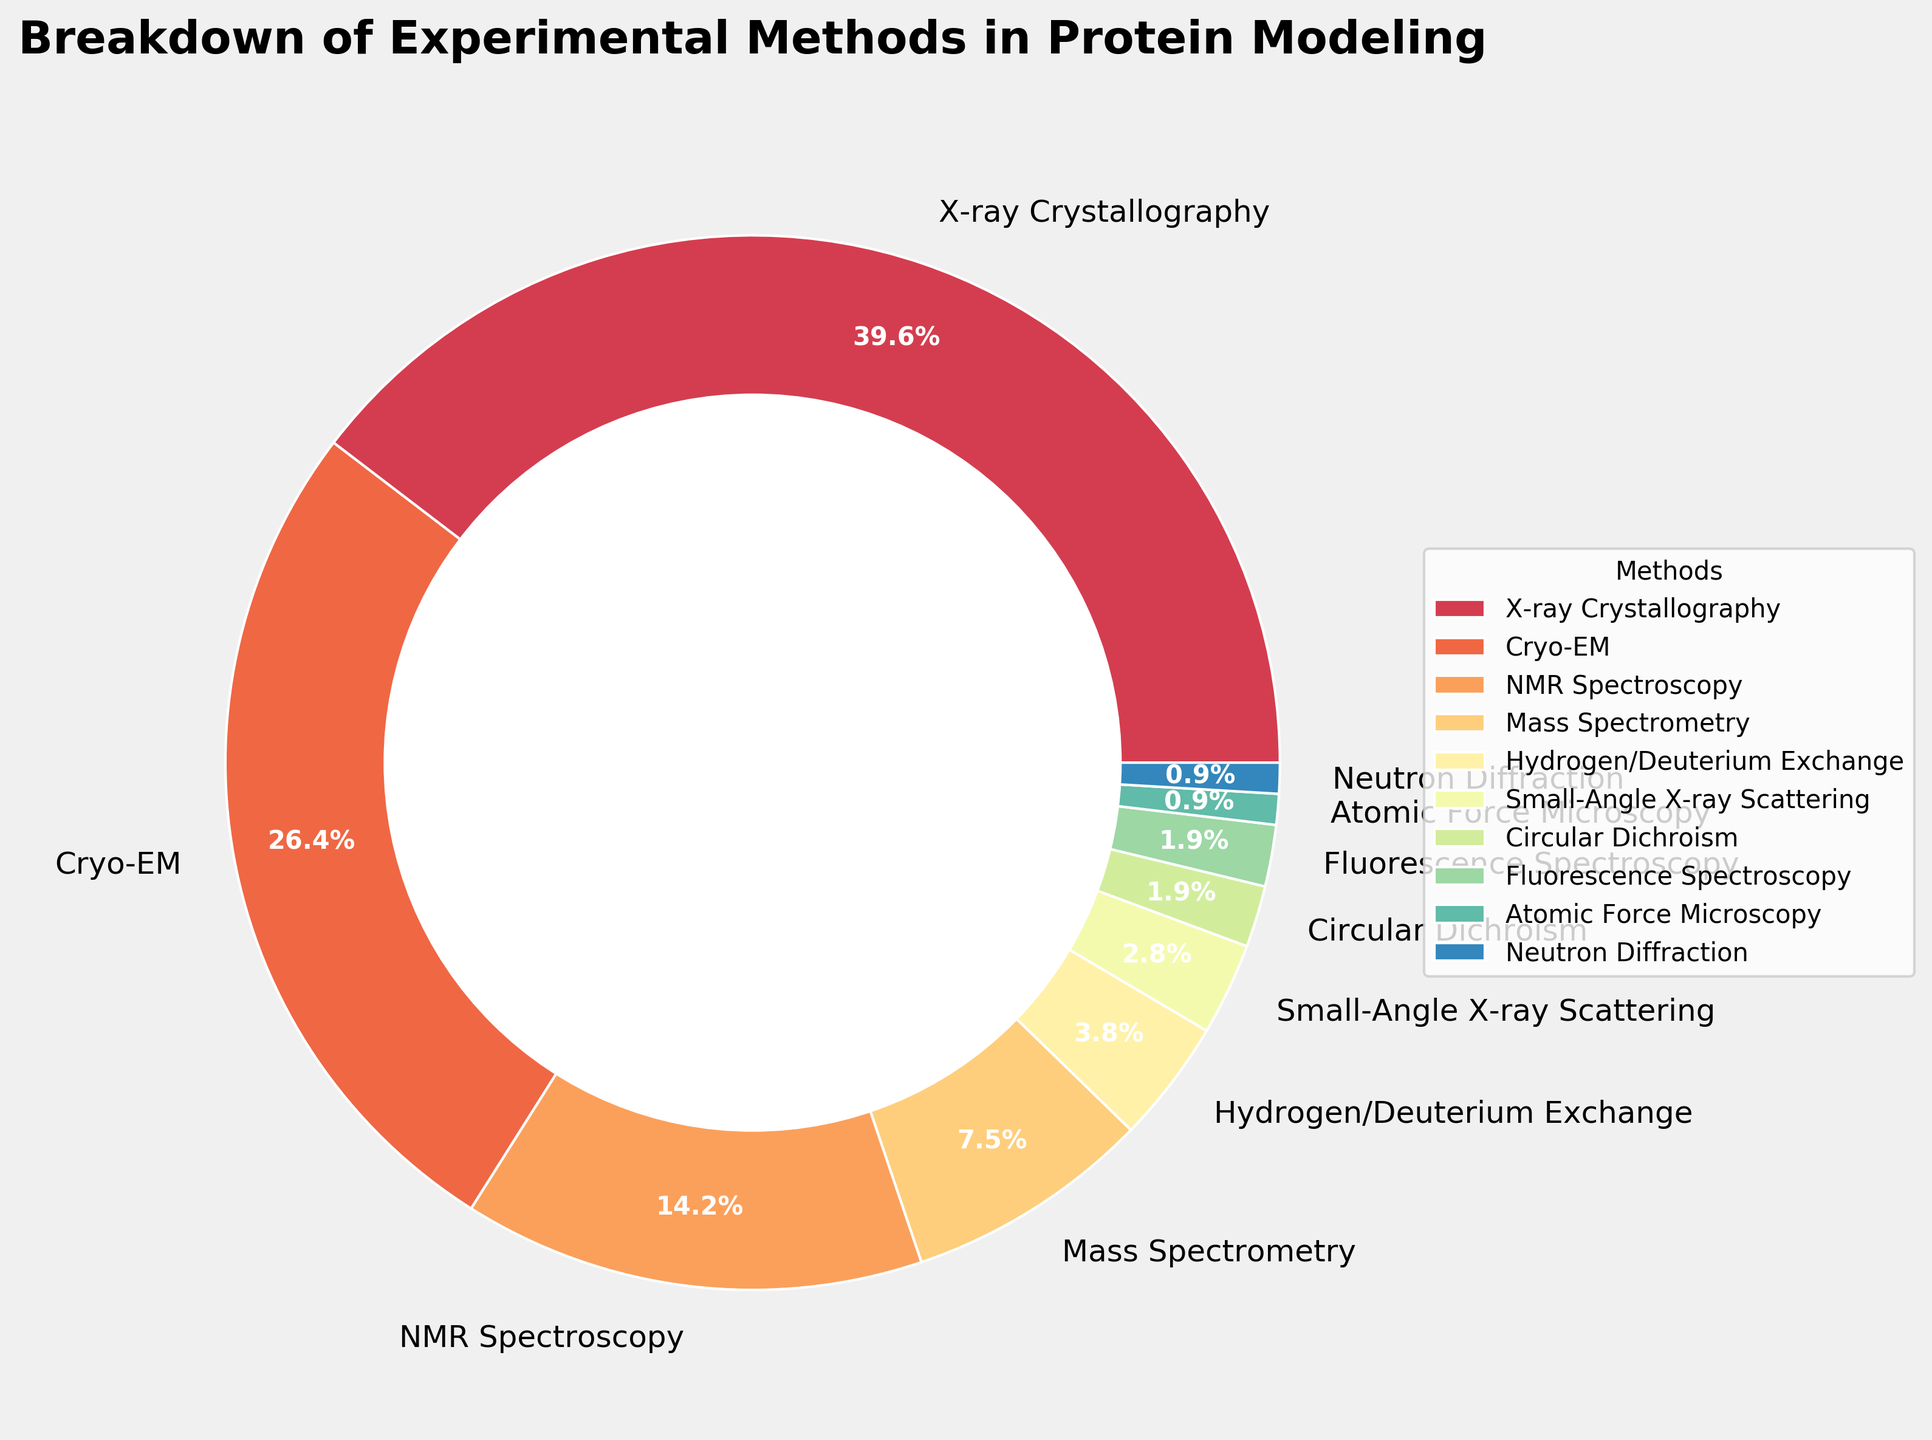Which experimental method is the most frequently used in protein modeling? The figure shows the percentages for each method, with the largest segment representing the most used method. The largest segment is X-ray Crystallography.
Answer: X-ray Crystallography Which two experimental methods are used less than 5% of the time? By examining the labels and their corresponding percentage values, we see that the methods with less than 5% each are Hydrogen/Deuterium Exchange (4%), Small-Angle X-ray Scattering (3%), Circular Dichroism (2%), Fluorescence Spectroscopy (2%), Atomic Force Microscopy (1%), and Neutron Diffraction (1%). However, the first two fit the criterion exactly at 5% or less.
Answer: Hydrogen/Deuterium Exchange, Small-Angle X-ray Scattering Which method is used more frequently, Cryo-EM or NMR Spectroscopy? The figure shows the percentages for Cryo-EM and NMR Spectroscopy. Cryo-EM has 28% while NMR Spectroscopy has 15%. 28% is greater than 15%.
Answer: Cryo-EM What is the combined percentage of the least used methods (those with 2% or less usage)? The methods with 2% or less usage are Circular Dichroism (2%), Fluorescence Spectroscopy (2%), Atomic Force Microscopy (1%), and Neutron Diffraction (1%). Summing these up: 2% + 2% + 1% + 1% = 6%.
Answer: 6% The methods are counted by the number of unique labels presented in the pie chart. There are 10 different methods listed: X-ray Crystallography, Cryo-EM, NMR Spectroscopy, Mass Spectrometry, Hydrogen/Deuterium Exchange, Small-Angle X-ray Scattering, Circular Dichroism, Fluorescence Spectroscopy, Atomic Force Microscopy, and Neutron Diffraction.
Answer: 10 What is the visual style/color representation used for the most frequently used method? The method with the largest segment (most frequently used) is X-ray Crystallography. The color can be visually identified by looking at the largest segment in the pie chart.
Answer: The visual style/color is primarily decided based on the colormap gradient but exact color needs visual verification from the pie chart If you combined Cryo-EM and Mass Spectrometry, would their percentage exceed that of X-ray Crystallography? The combined percentage of Cryo-EM and Mass Spectrometry is 28% + 8% = 36%, while X-ray Crystallography's percentage is 42%. 42% is greater than 36%.
Answer: No Which method occupies the smallest area of the pie chart, and what is its percentage? The smallest wedge in the pie chart corresponds to the method with the lowest percentage. According to the figure, Atomic Force Microscopy and Neutron Diffraction both have the lowest percentage of 1%.
Answer: Atomic Force Microscopy and Neutron Diffraction, 1% What proportion of the methods have a usage percentage of 10% or higher? Methods with a percentage of 10% or higher are X-ray Crystallography (42%), Cryo-EM (28%), and NMR Spectroscopy (15%). Out of 10 methods, these three meet the criterion.
Answer: 30% (3 out of 10 methods) 